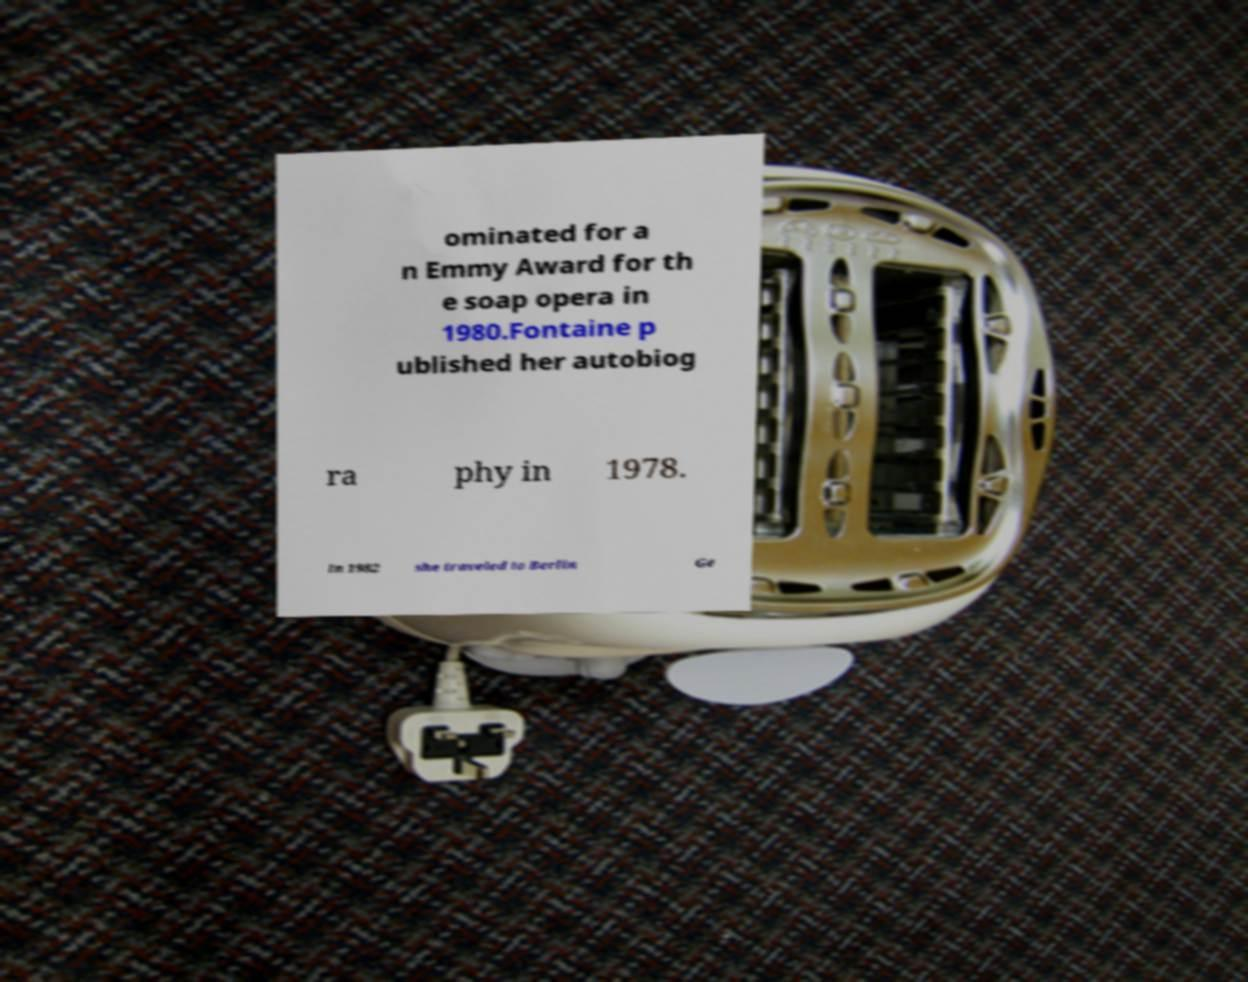I need the written content from this picture converted into text. Can you do that? ominated for a n Emmy Award for th e soap opera in 1980.Fontaine p ublished her autobiog ra phy in 1978. In 1982 she traveled to Berlin Ge 